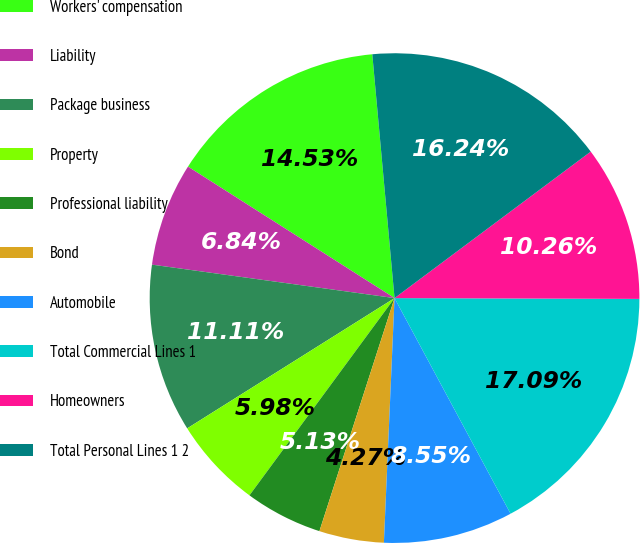<chart> <loc_0><loc_0><loc_500><loc_500><pie_chart><fcel>Workers' compensation<fcel>Liability<fcel>Package business<fcel>Property<fcel>Professional liability<fcel>Bond<fcel>Automobile<fcel>Total Commercial Lines 1<fcel>Homeowners<fcel>Total Personal Lines 1 2<nl><fcel>14.53%<fcel>6.84%<fcel>11.11%<fcel>5.98%<fcel>5.13%<fcel>4.27%<fcel>8.55%<fcel>17.09%<fcel>10.26%<fcel>16.24%<nl></chart> 